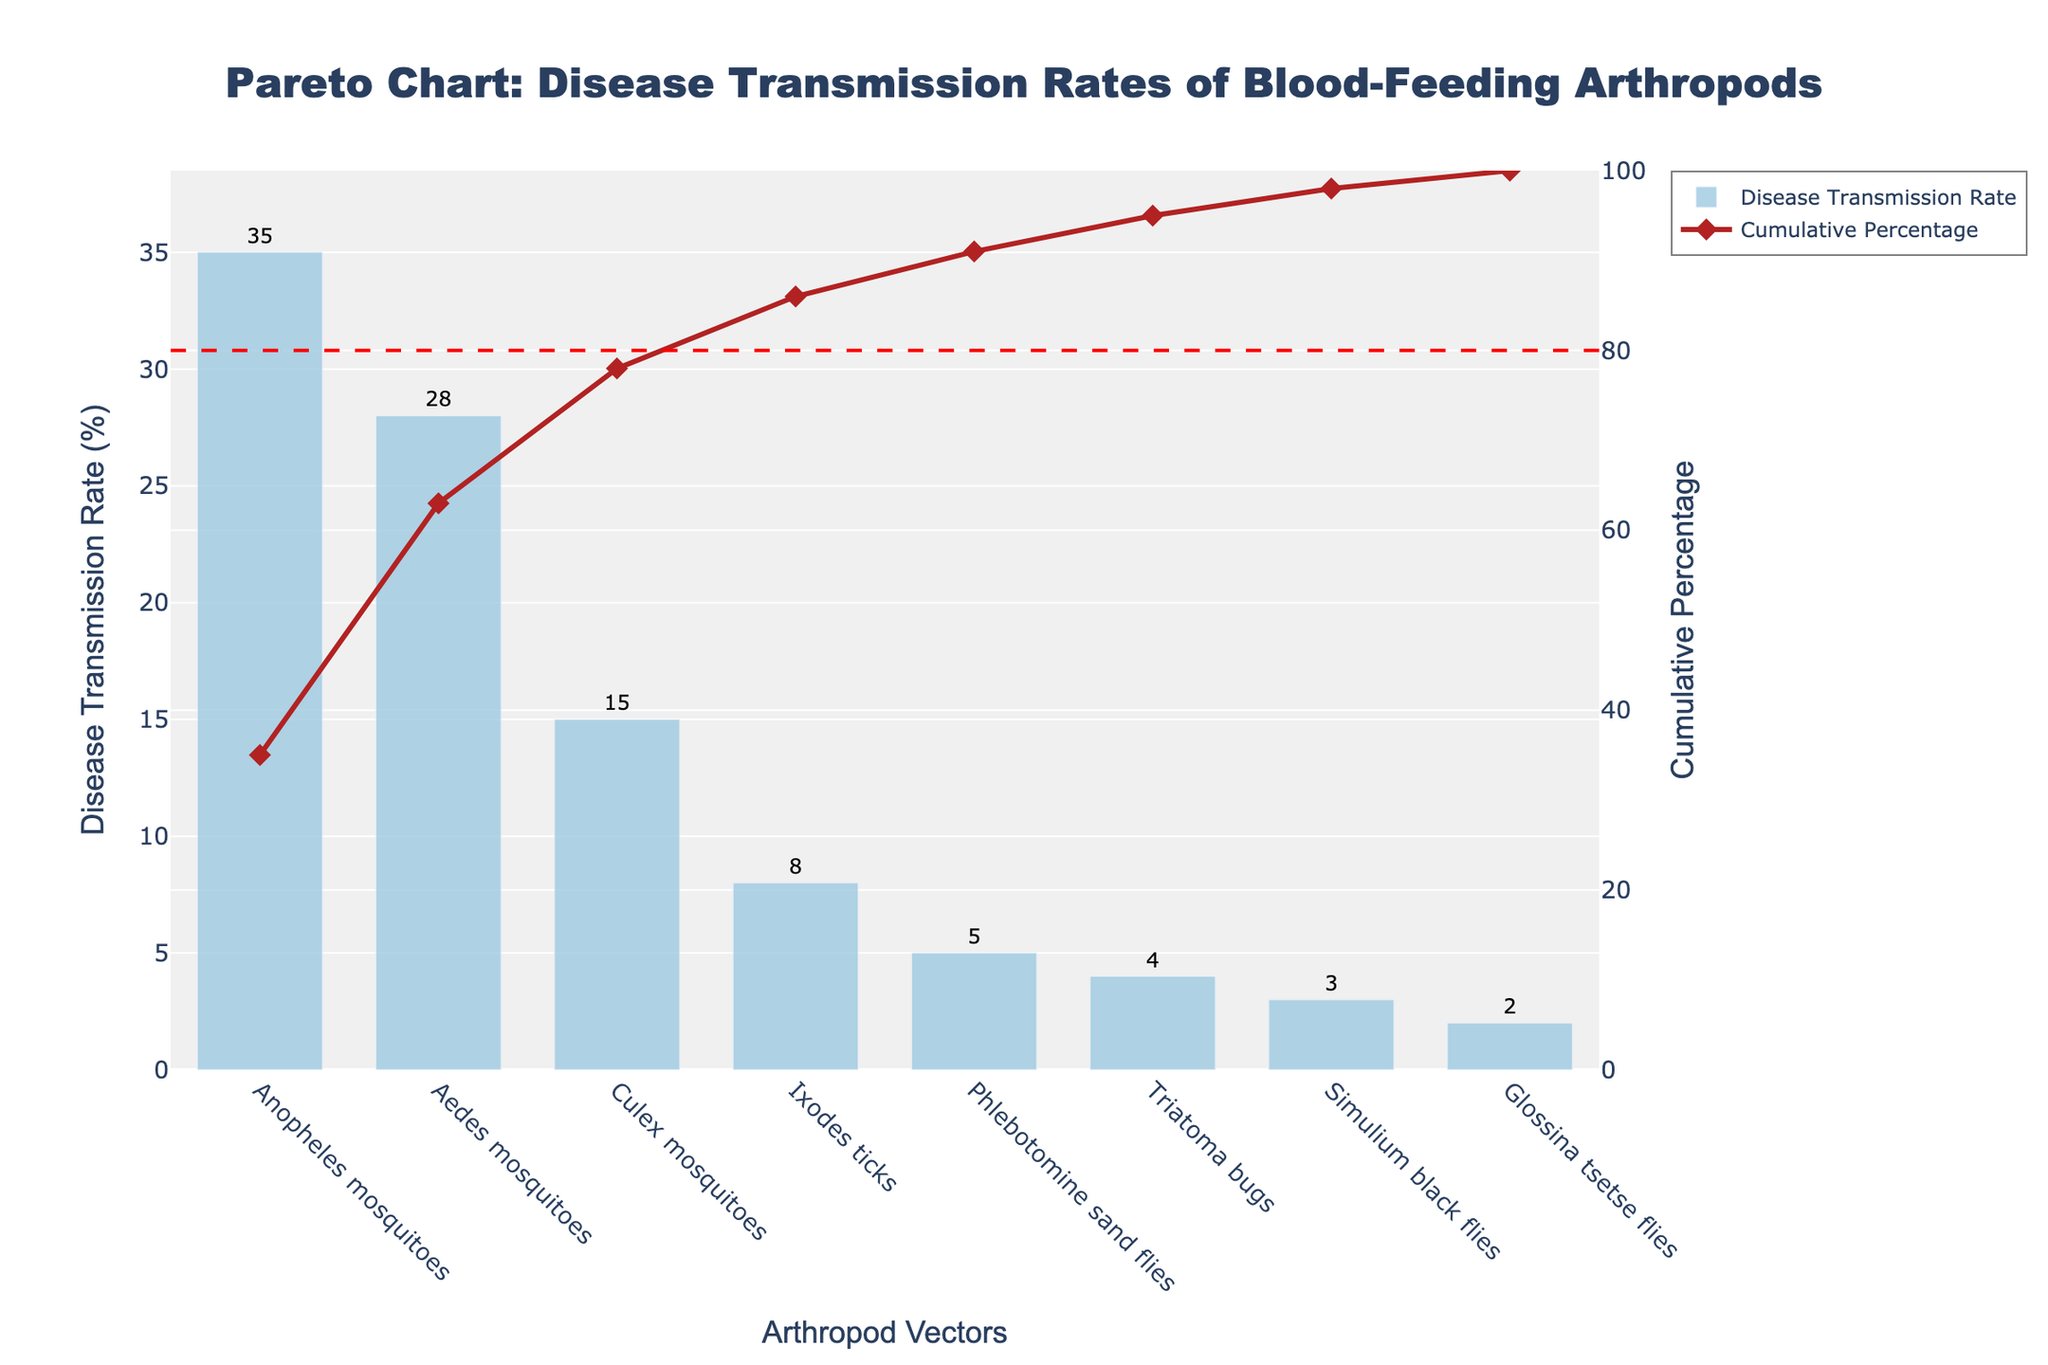What is the title of the chart? The title of the chart is located at the top and reads, 'Pareto Chart: Disease Transmission Rates of Blood-Feeding Arthropods'.
Answer: Pareto Chart: Disease Transmission Rates of Blood-Feeding Arthropods Which arthropod vector has the highest disease transmission rate? By examining the bar heights, the highest bar represents 'Anopheles mosquitoes' with a disease transmission rate of 35%.
Answer: Anopheles mosquitoes What is the cumulative percentage after including Culex mosquitoes? Culex mosquitoes are accounted third, with cumulative percentages being 35% from Anopheles, 28% from Aedes, and 15% from Culex. Summing these up gives 35 + 28 + 15 = 78%.
Answer: 78% How do the disease transmission rates of Ixodes ticks compare to Triatoma bugs? Compare the heights of the bars: Ixodes ticks have a transmission rate of 8%, while Triatoma bugs have a rate of 4%. 8% is greater than 4%.
Answer: Ixodes ticks have a higher rate What proportion of the total transmission rate is accounted by the three most significant vectors? The total transmission rates for the top three vectors are 35% (Anopheles), 28% (Aedes), and 15% (Culex). The sum is 35 + 28 + 15 = 78%. To find the proportion: 78% of 100% = 78%.
Answer: 78% What color represents the cumulative percentage line? The cumulative percentage line is represented by a firebrick color.
Answer: Firebrick By the 80% cumulative percentage line, which arthropods are primarily responsible for disease transmission? According to the chart, the first four vectors (Anopheles, Aedes, Culex, and Ixodes) are the primary contributors reaching up to 86% of the cumulative percentage.
Answer: Anopheles, Aedes, Culex, Ixodes What is the difference in disease transmission rates between Phlebotomine sand flies and Glossina tsetse flies? Phlebotomine sand flies have a rate of 5%, while Glossina tsetse flies have a rate of 2%. The difference is 5 - 2 = 3%.
Answer: 3% Based on the chart, which arthropod vector has the smallest contribution to the cumulative percentage? The smallest bar, indicating the least contribution, belongs to 'Glossina tsetse flies' with a cumulative percentage of 100%.
Answer: Glossina tsetse flies How many arthropod vectors are shown in the chart? Count the number of bars or data points in the chart, which represent the different arthropod vectors. There are 8 vectors displayed.
Answer: 8 